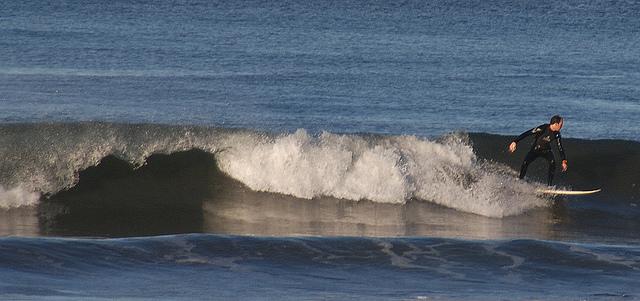Is the water calm?
Keep it brief. No. What is the man standing on?
Give a very brief answer. Surfboard. How tall is the wave?
Give a very brief answer. 4 feet. Is there anyone else surfing?
Write a very short answer. No. Is the man going to fall?
Write a very short answer. No. 